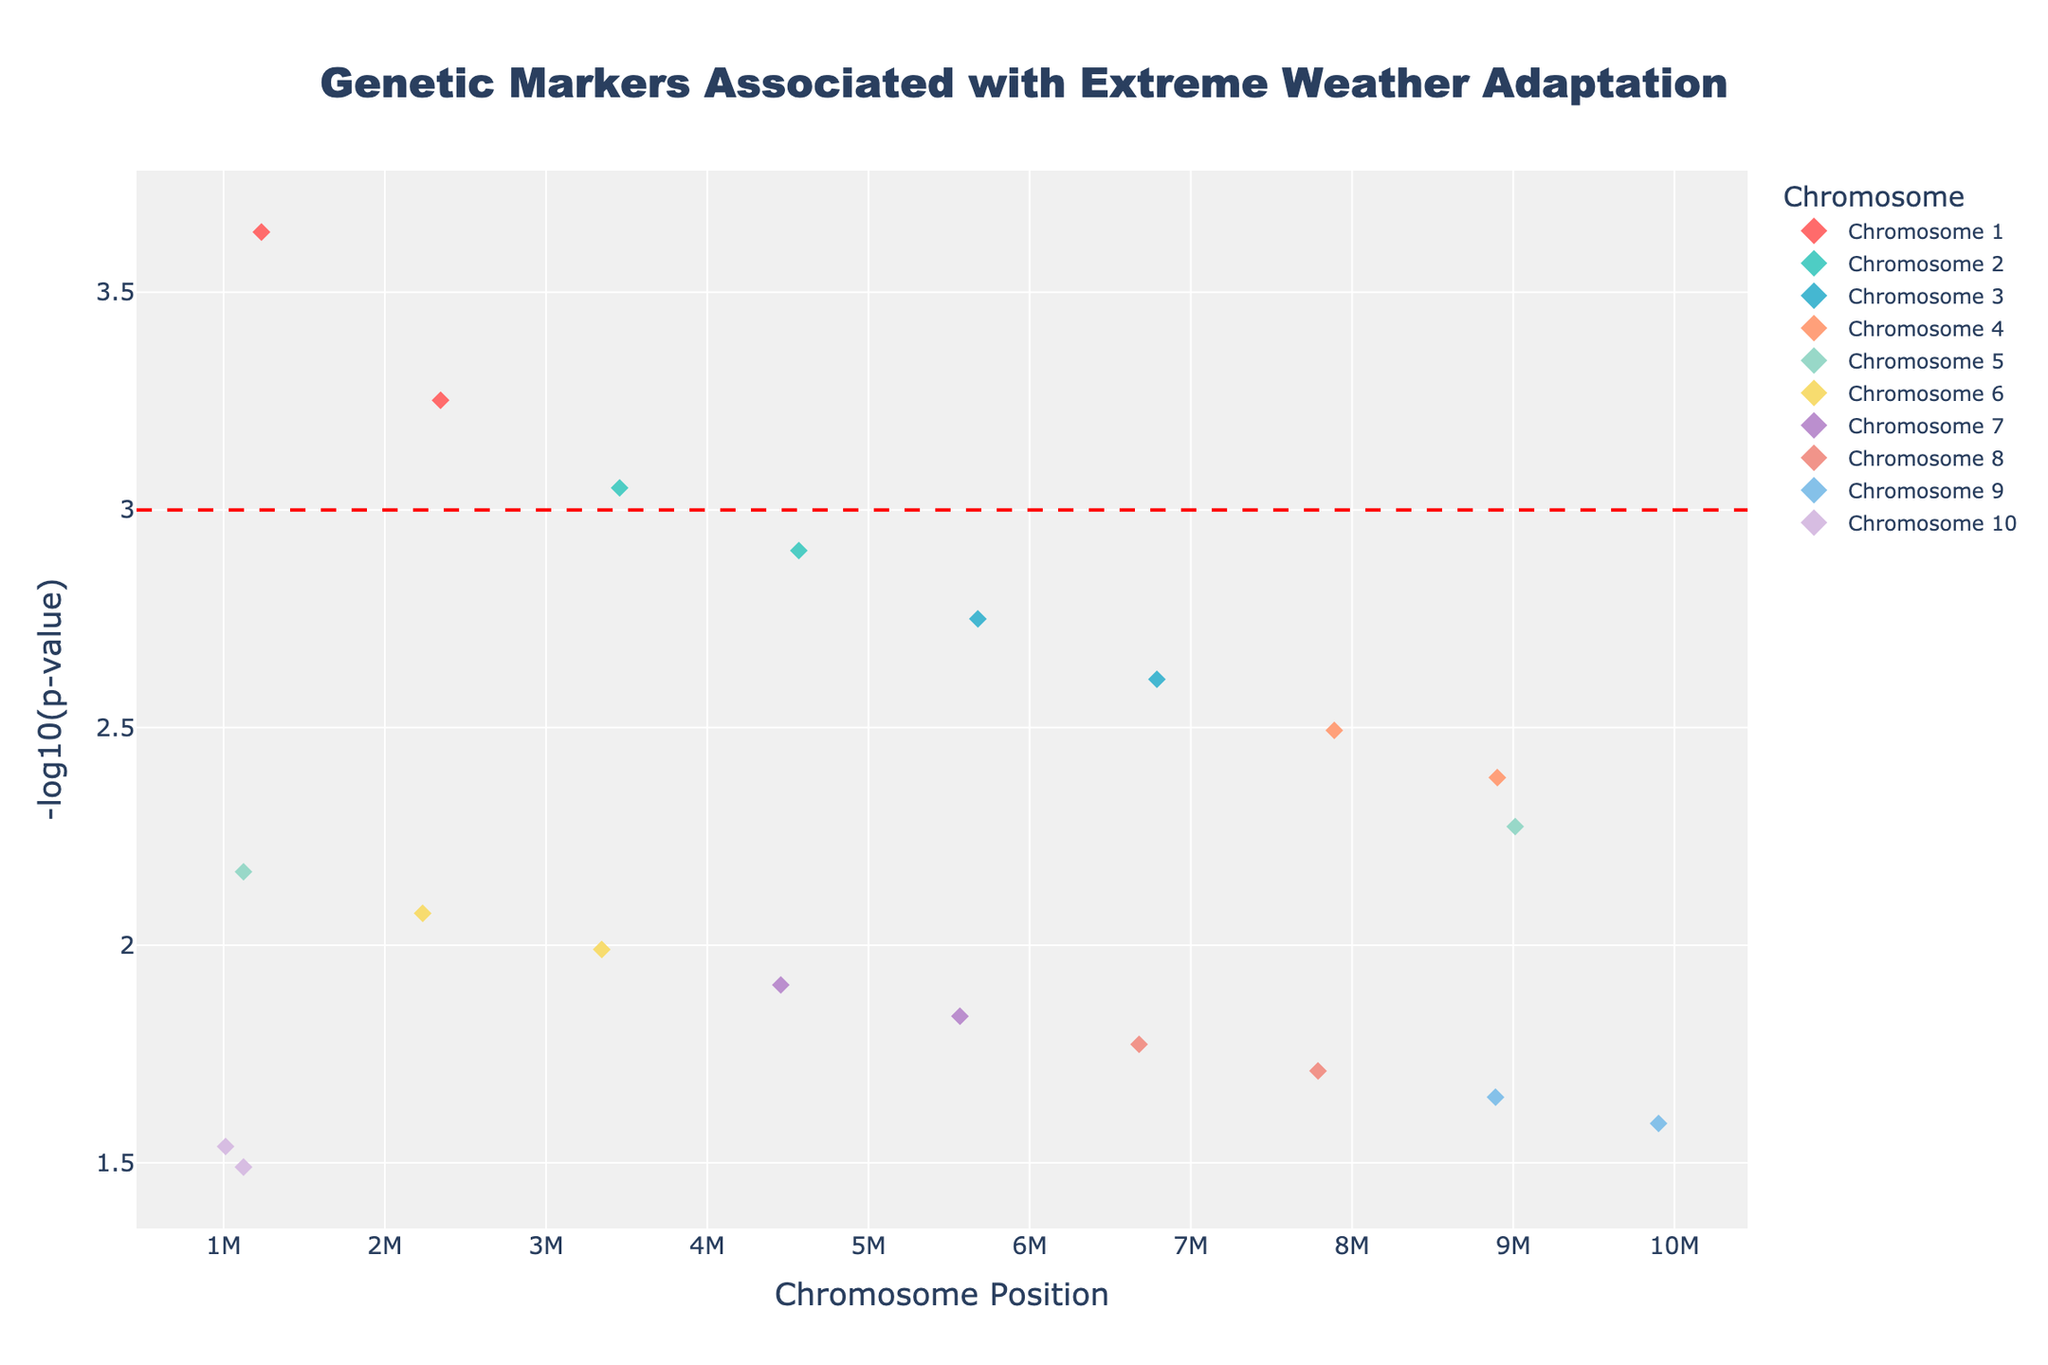How many chromosomes are included in the study? By looking at the different colors and labels on the plot, we can see each unique chromosome represented in the legend on the right side. There are 10 colors corresponding to 10 different chromosomes.
Answer: 10 What is the title of the plot? The title of the plot is displayed at the top center and reads: 'Genetic Markers Associated with Extreme Weather Adaptation'.
Answer: Genetic Markers Associated with Extreme Weather Adaptation What is the y-axis measuring? The y-axis is labeled with '-log10(p-value)' and represents the log-transformed p-values of the genetic markers.
Answer: -log10(p-value) Which chromosome has the highest number of significant genetic markers? To determine this, observe the points close to or below the significance threshold line (red dashed). Chromosome 1 and Chromosome 2 seem to have fewer points when compared to others. Chromosome 5 has a few markers, while chromosomes 3, 4, and 7 stand out with more markers at lower p-values. Chromosomes 3 and 4 each have two markers, and overall they appear most significant.
Answer: Chromosomes 3 and 4 (Tie) Which gene is associated with the lowest p-value? By looking at the highest values on the y-axis (since we are dealing with -log10(p-value)), the point that is highest corresponds to BRCA1 on Chromosome 1, which has the lowest p-value.
Answer: BRCA1 Compare the significance of the genetic marker at chromosome 2, position 4567890 with chromosome 8, position 6678901. Which is more significant? For comparison, look at the y-axis values for these points. Chromosome 2, position 4567890 (KRAS) has a higher -log10(p-value) than chromosome 8, position 6678901 (MYC), indicating KRAS is more significant.
Answer: KRAS What is the purpose of the horizontal red dashed line? The red dashed line represents the significance threshold, typically set at a p-value (here: -log10(p-value) = 3). Genetic markers above this line are considered statistically significant.
Answer: Significance threshold Which chromosome shows a significant association with 'Cyclone survival'? For the trait 'Cyclone survival', observe the hovertext. ERBB2 on Chromosome 7 shows an association with Cyclone survival; it is significantly above the red dashed line.
Answer: Chromosome 7 Rank the chromosomes by their number of genetic markers with p-values below 0.01, from highest to lowest. Review the plot and count the markers below the 3 on the y-axis for each chromosome. Chromosome 3, 4, and 7 each have two points. All other chromosomes have fewer markers below this threshold.
Answer: Chromosome 3 = Chromosome 4 = Chromosome 7 > Others 